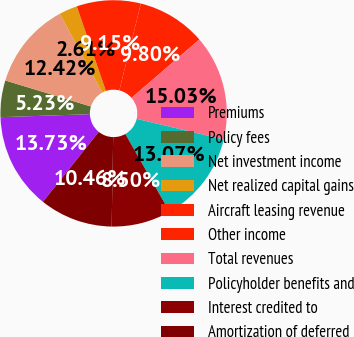<chart> <loc_0><loc_0><loc_500><loc_500><pie_chart><fcel>Premiums<fcel>Policy fees<fcel>Net investment income<fcel>Net realized capital gains<fcel>Aircraft leasing revenue<fcel>Other income<fcel>Total revenues<fcel>Policyholder benefits and<fcel>Interest credited to<fcel>Amortization of deferred<nl><fcel>13.73%<fcel>5.23%<fcel>12.42%<fcel>2.61%<fcel>9.15%<fcel>9.8%<fcel>15.03%<fcel>13.07%<fcel>8.5%<fcel>10.46%<nl></chart> 